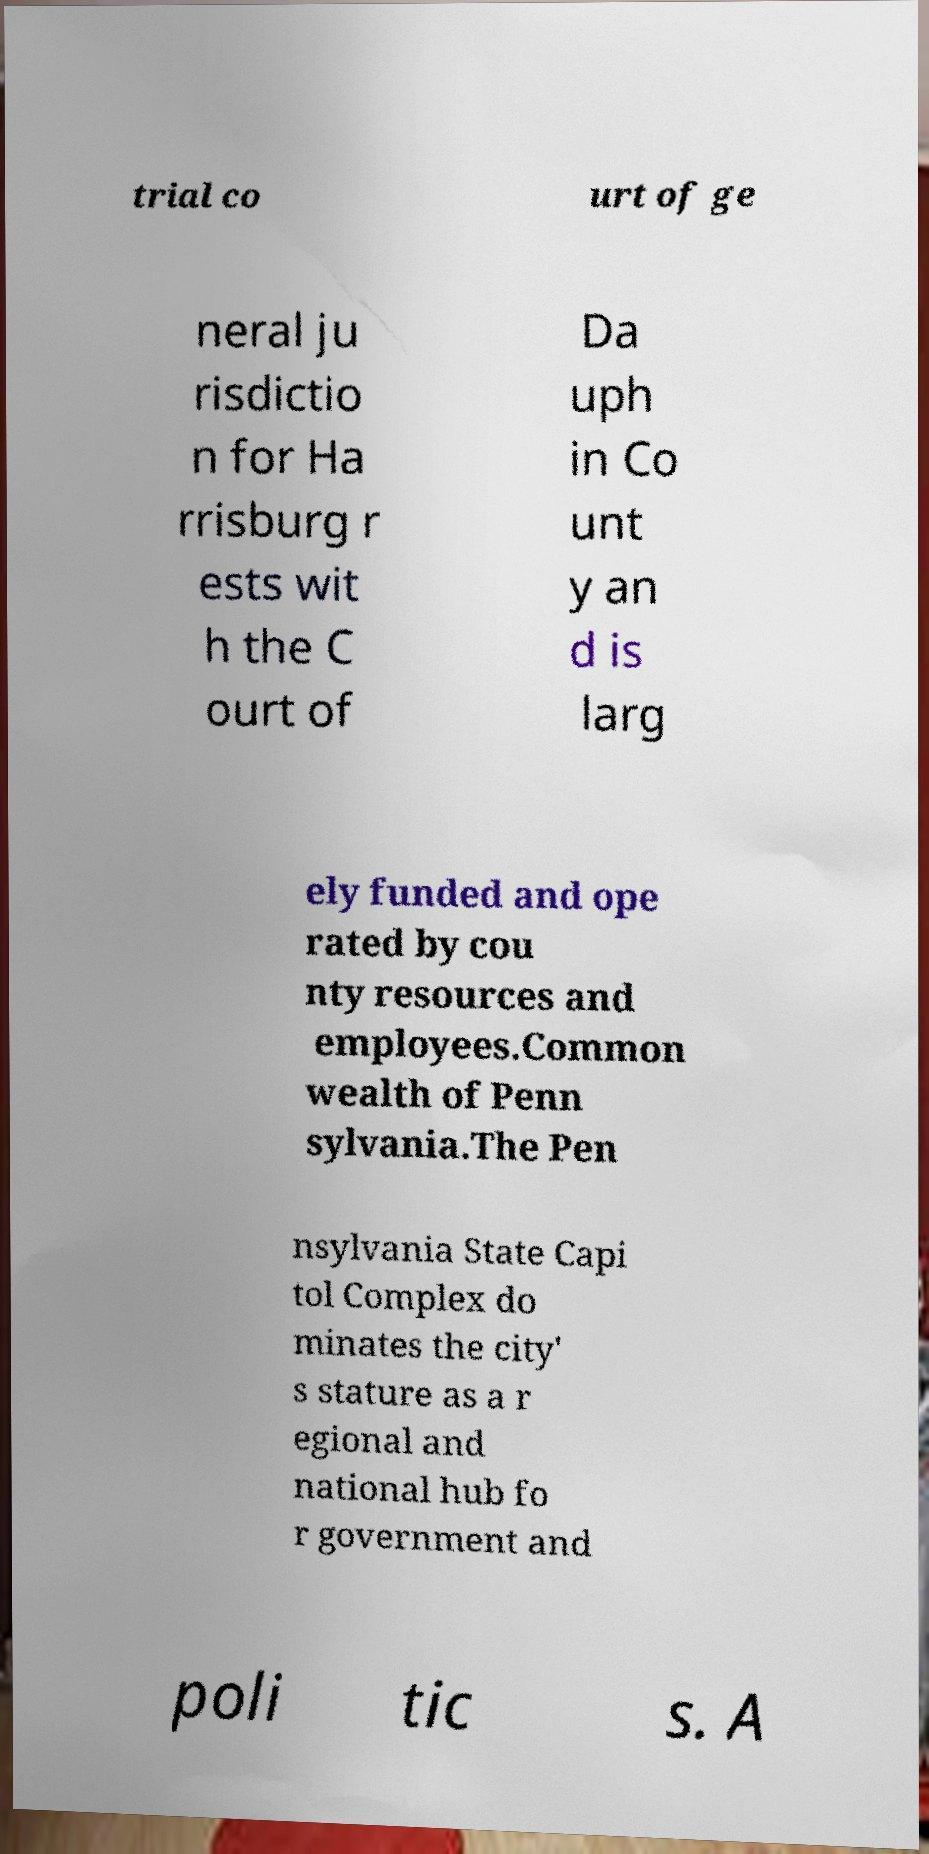Please identify and transcribe the text found in this image. trial co urt of ge neral ju risdictio n for Ha rrisburg r ests wit h the C ourt of Da uph in Co unt y an d is larg ely funded and ope rated by cou nty resources and employees.Common wealth of Penn sylvania.The Pen nsylvania State Capi tol Complex do minates the city' s stature as a r egional and national hub fo r government and poli tic s. A 